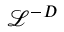Convert formula to latex. <formula><loc_0><loc_0><loc_500><loc_500>\mathcal { L } ^ { - D }</formula> 